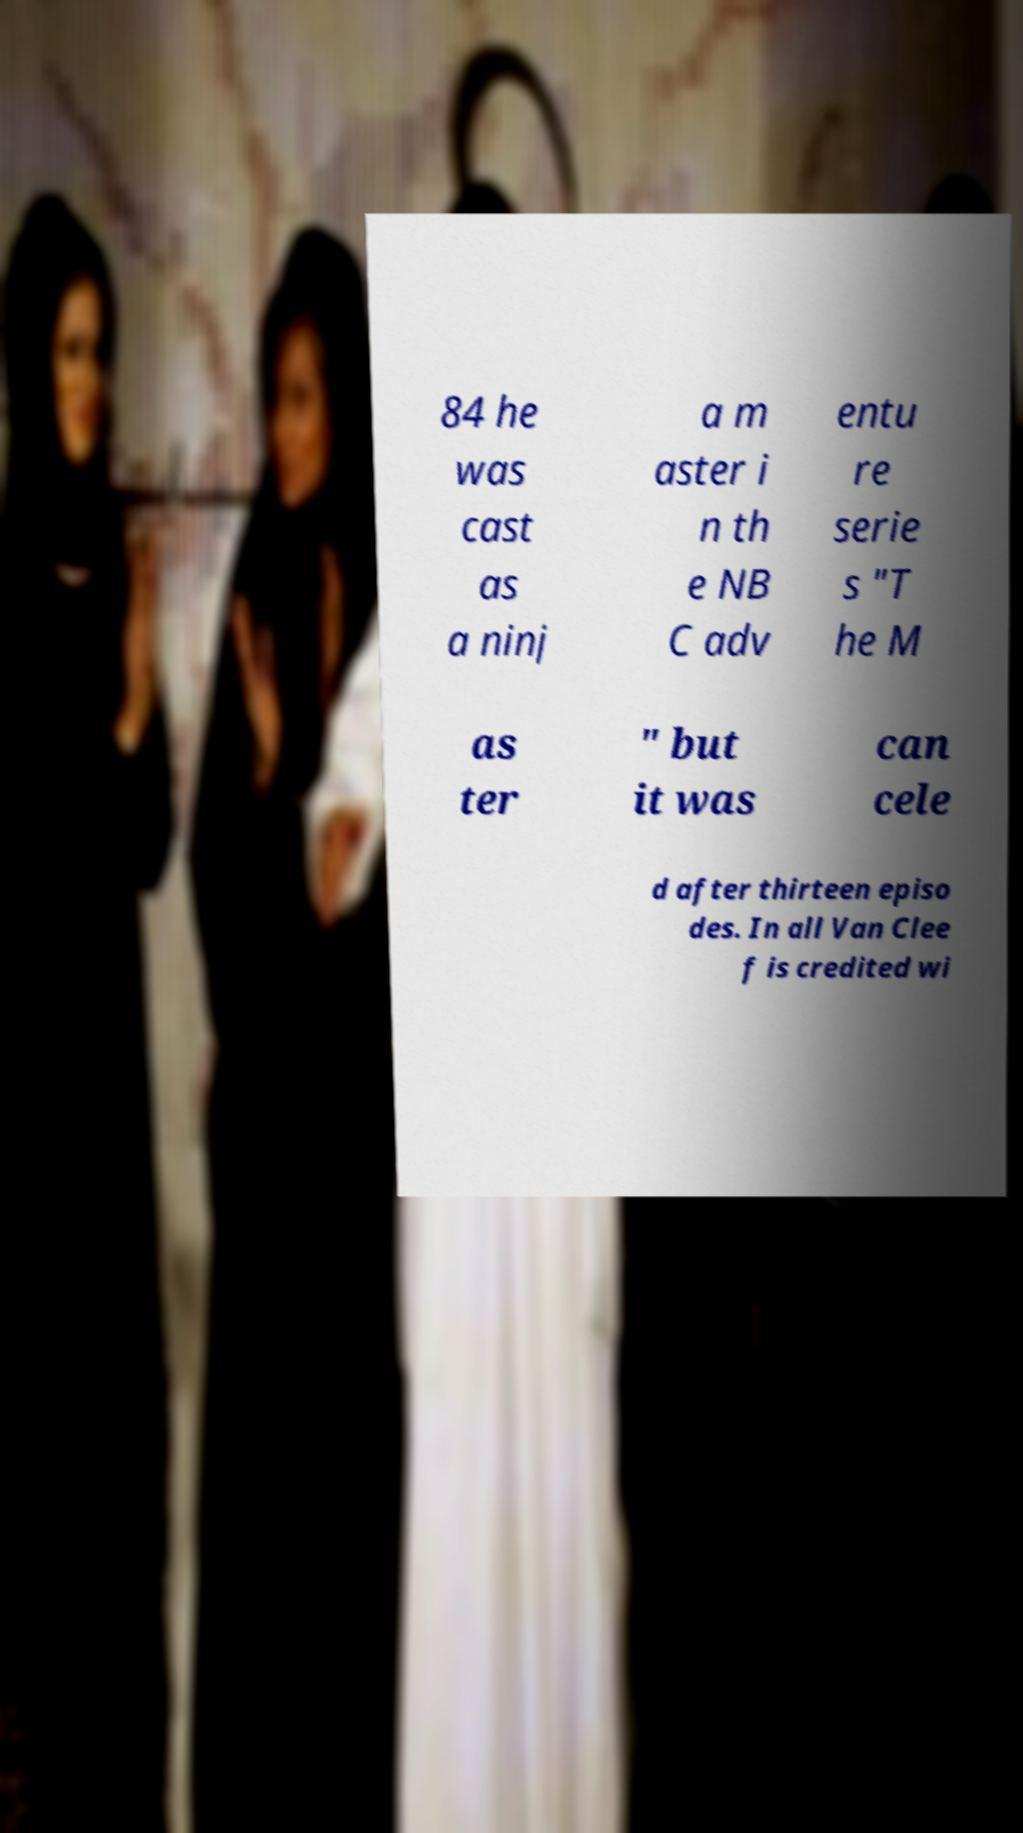I need the written content from this picture converted into text. Can you do that? 84 he was cast as a ninj a m aster i n th e NB C adv entu re serie s "T he M as ter " but it was can cele d after thirteen episo des. In all Van Clee f is credited wi 